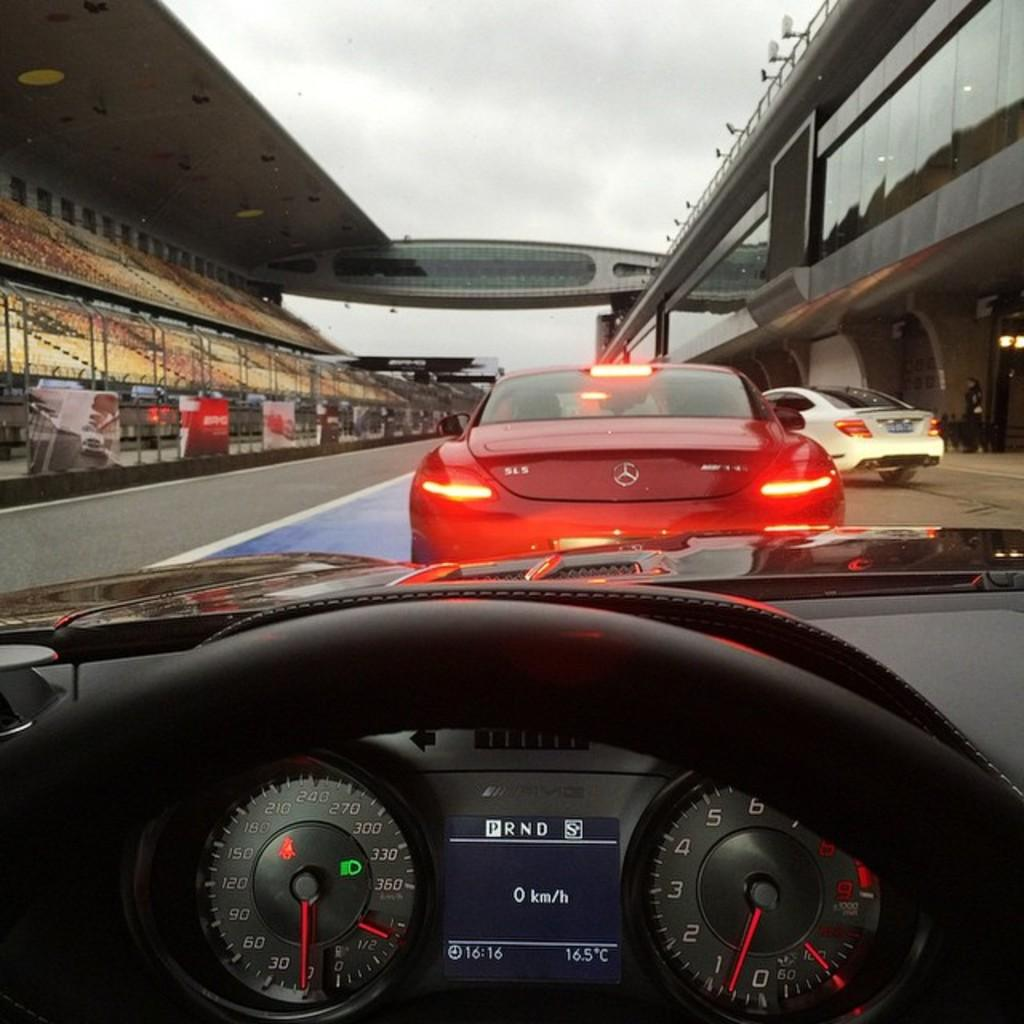What is happening on the road in the image? There are cars riding on the road in the image. What structure is located beside the road in the image? There is a stadium beside the road in the image. Can you see a river flowing beside the stadium in the image? There is no river visible in the image; it only shows cars on the road and a stadium beside it. What type of spark can be seen coming from the cars in the image? There are no sparks visible coming from the cars in the image. 